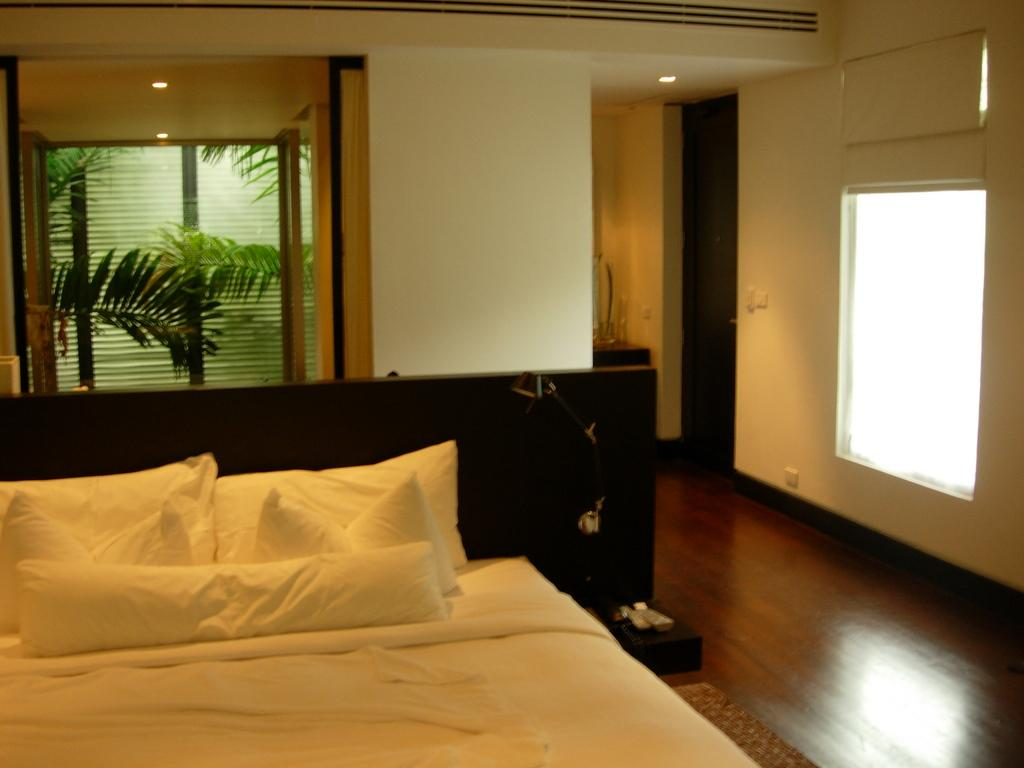What type of space is shown in the image? The image is of the inside of a room. What furniture is present in the room? There is a bed in the room. What are the pillows used for in the room? The pillows are on or near the bed, likely for comfort while sleeping or resting. What can be seen through the window in the room? Plants are visible through the window. What type of income can be seen in the image? There is no reference to income in the image; it is a room with a bed, pillows, and a window with plants outside. 